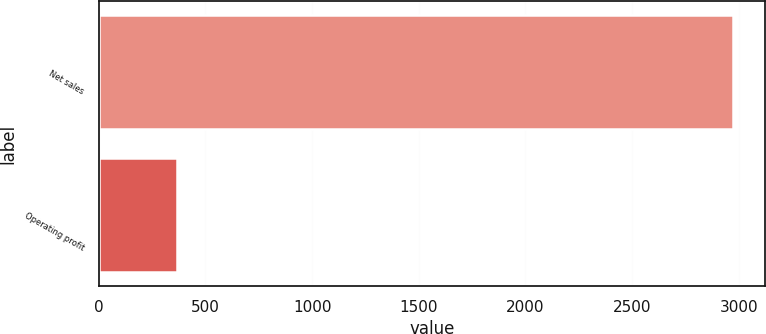Convert chart to OTSL. <chart><loc_0><loc_0><loc_500><loc_500><bar_chart><fcel>Net sales<fcel>Operating profit<nl><fcel>2975<fcel>367<nl></chart> 